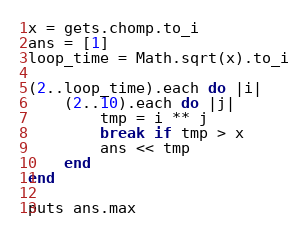<code> <loc_0><loc_0><loc_500><loc_500><_Ruby_>x = gets.chomp.to_i
ans = [1]
loop_time = Math.sqrt(x).to_i

(2..loop_time).each do |i|
    (2..10).each do |j|
        tmp = i ** j
        break if tmp > x
        ans << tmp
    end
end

puts ans.max</code> 